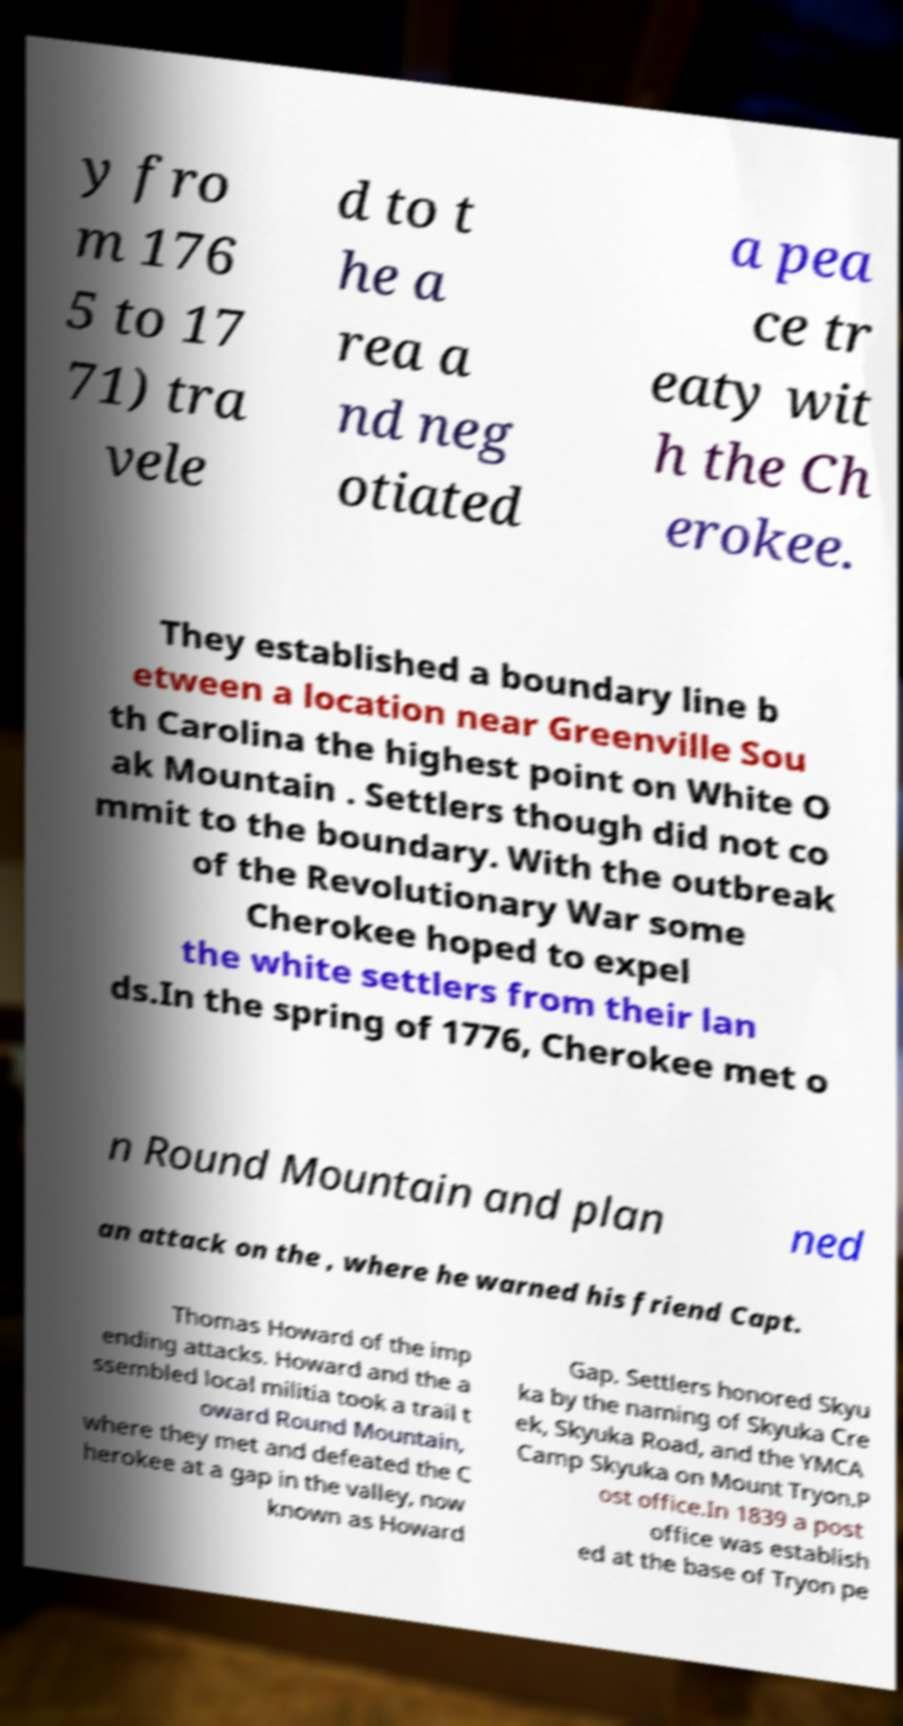I need the written content from this picture converted into text. Can you do that? y fro m 176 5 to 17 71) tra vele d to t he a rea a nd neg otiated a pea ce tr eaty wit h the Ch erokee. They established a boundary line b etween a location near Greenville Sou th Carolina the highest point on White O ak Mountain . Settlers though did not co mmit to the boundary. With the outbreak of the Revolutionary War some Cherokee hoped to expel the white settlers from their lan ds.In the spring of 1776, Cherokee met o n Round Mountain and plan ned an attack on the , where he warned his friend Capt. Thomas Howard of the imp ending attacks. Howard and the a ssembled local militia took a trail t oward Round Mountain, where they met and defeated the C herokee at a gap in the valley, now known as Howard Gap. Settlers honored Skyu ka by the naming of Skyuka Cre ek, Skyuka Road, and the YMCA Camp Skyuka on Mount Tryon.P ost office.In 1839 a post office was establish ed at the base of Tryon pe 